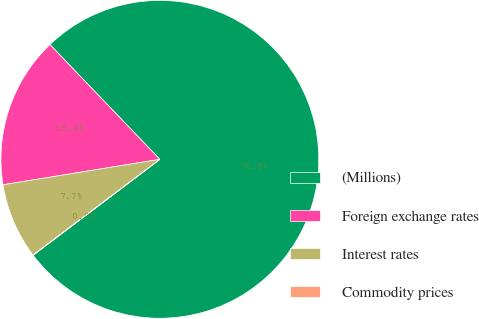<chart> <loc_0><loc_0><loc_500><loc_500><pie_chart><fcel>(Millions)<fcel>Foreign exchange rates<fcel>Interest rates<fcel>Commodity prices<nl><fcel>76.84%<fcel>15.4%<fcel>7.72%<fcel>0.04%<nl></chart> 